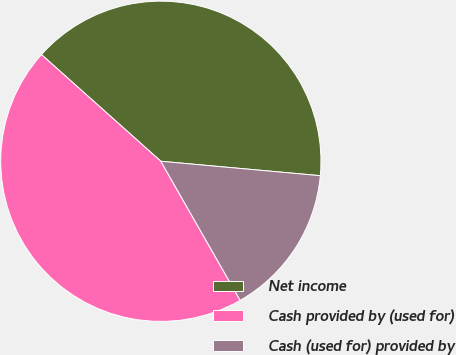Convert chart. <chart><loc_0><loc_0><loc_500><loc_500><pie_chart><fcel>Net income<fcel>Cash provided by (used for)<fcel>Cash (used for) provided by<nl><fcel>39.83%<fcel>44.86%<fcel>15.31%<nl></chart> 